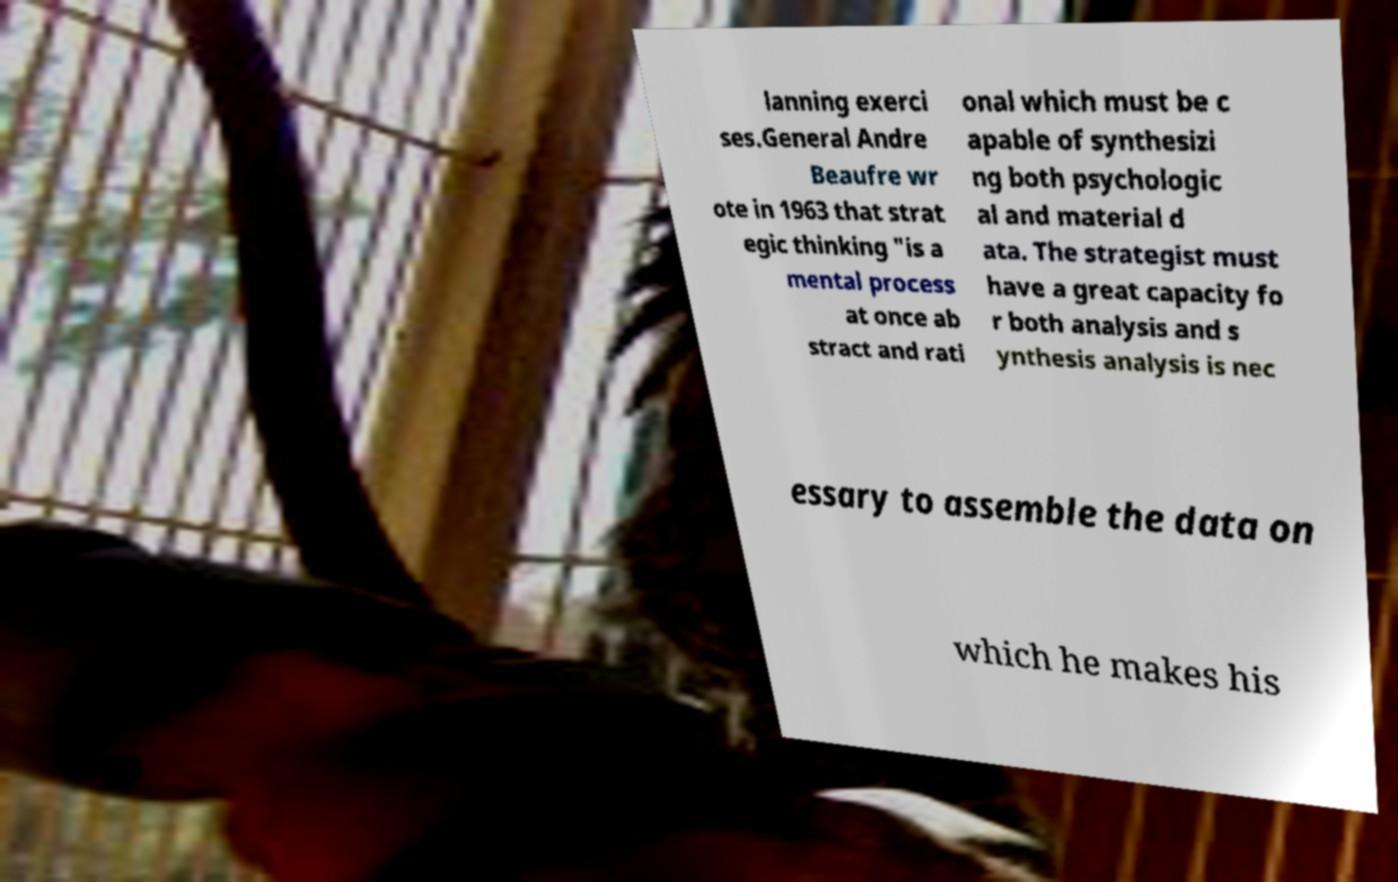I need the written content from this picture converted into text. Can you do that? lanning exerci ses.General Andre Beaufre wr ote in 1963 that strat egic thinking "is a mental process at once ab stract and rati onal which must be c apable of synthesizi ng both psychologic al and material d ata. The strategist must have a great capacity fo r both analysis and s ynthesis analysis is nec essary to assemble the data on which he makes his 